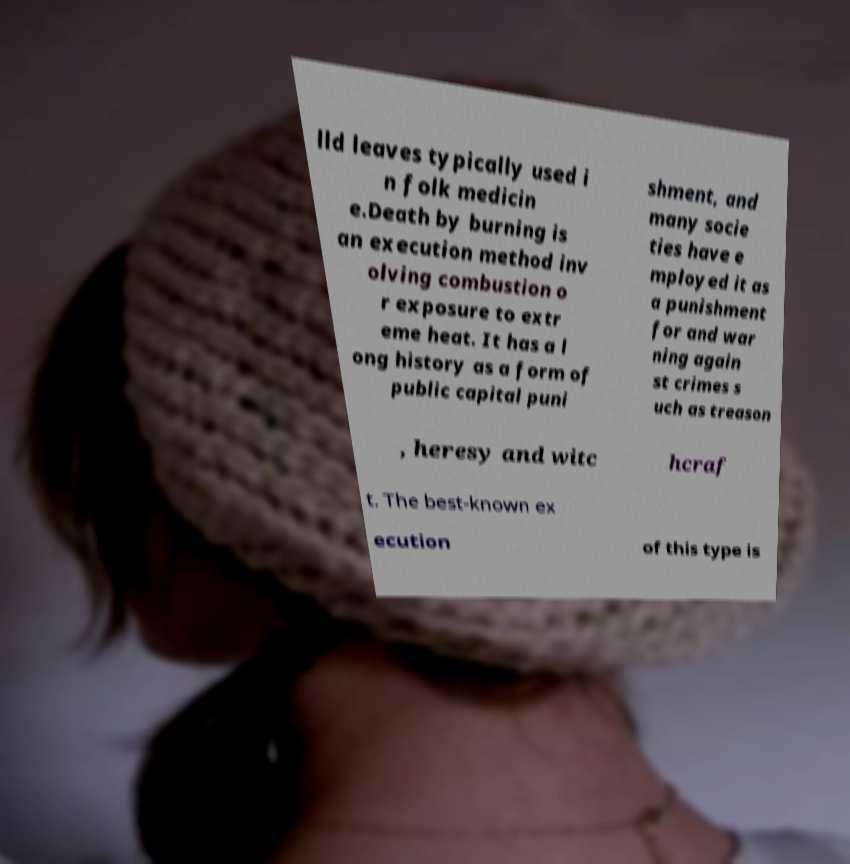Can you read and provide the text displayed in the image?This photo seems to have some interesting text. Can you extract and type it out for me? lld leaves typically used i n folk medicin e.Death by burning is an execution method inv olving combustion o r exposure to extr eme heat. It has a l ong history as a form of public capital puni shment, and many socie ties have e mployed it as a punishment for and war ning again st crimes s uch as treason , heresy and witc hcraf t. The best-known ex ecution of this type is 